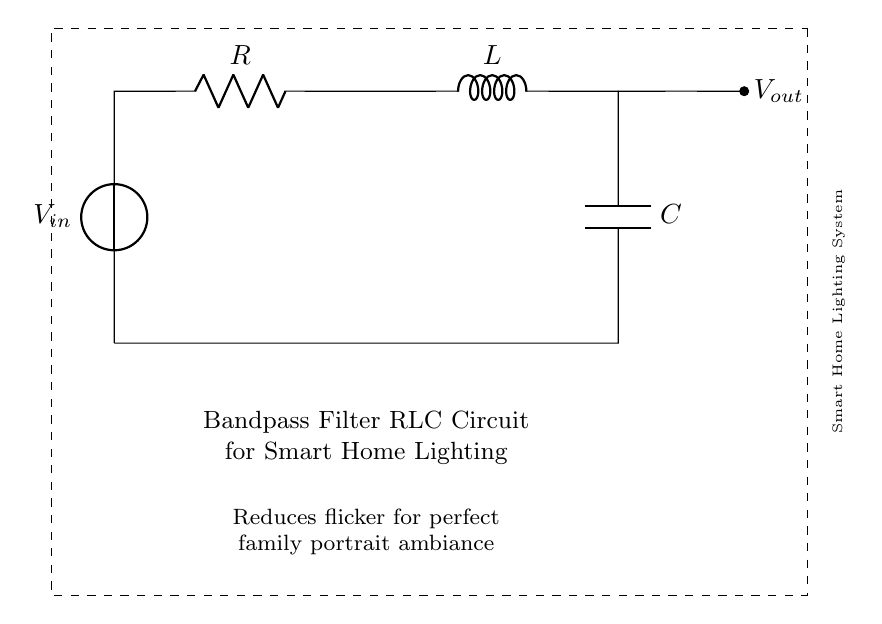What is the input voltage of the circuit? The input voltage is represented by the voltage source labeled as V_in in the diagram. This voltage source provides the initial power needed for the circuit to operate.
Answer: V_in What type of filter is implemented in this circuit? The circuit is a bandpass filter since it allows signals within a certain frequency range to pass while attenuating signals outside that range. This is inferred from the specific arrangement of the resistor, inductor, and capacitor, which together define the frequency characteristics of the circuit.
Answer: Bandpass filter How many reactive components are present in the circuit? There are two reactive components: an inductor (L) and a capacitor (C). Reactive components are defined as those that store energy in an electric or magnetic field. The inductor stores energy in a magnetic field, while the capacitor stores energy in an electric field.
Answer: Two Where is the output voltage measured in this circuit? The output voltage (V_out) is measured at the point located to the right of the inductor, where it connects to the additional circuit. This indicates where the filtered output signal can be taken from the circuit.
Answer: To the right of the inductor What effect does this circuit have on family portraits? This circuit reduces flicker, providing a consistent and stable light output which is ideal for taking good quality family portraits. Flicker-free lighting enhances the overall appearance of photos by avoiding sudden changes in light intensity.
Answer: Reduces flicker What is the purpose of the resistor in the circuit? The resistor (R) in the circuit serves to limit the current and help control the behavior of the circuit, affecting the overall gain and bandwidth of the bandpass filter. It helps achieve stability and protects other components from excessive current.
Answer: Control current How does the combination of all components impact flicker? The combination of the resistor, inductor, and capacitor determines the frequency response of the circuit. This specific arrangement allows for the attenuation of unwanted frequencies (such as flicker) while allowing desired frequencies (such as ambient lighting) to pass effectively, thus achieving a flicker-free ambiance.
Answer: Attenuates flicker 